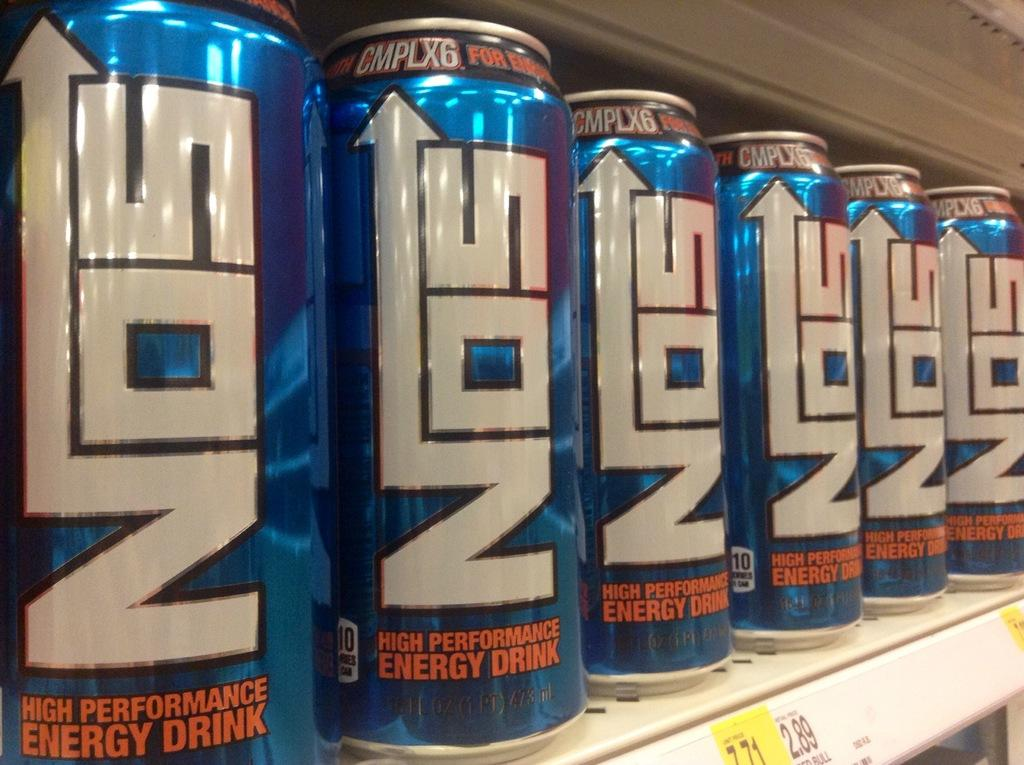<image>
Share a concise interpretation of the image provided. Many cans of NOS energy drink are lined up on a shelf in a store. 